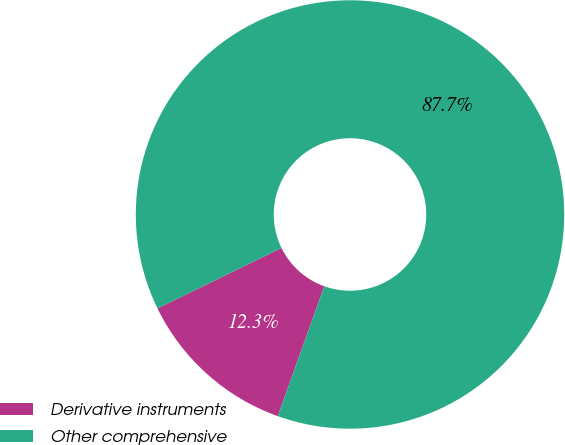Convert chart. <chart><loc_0><loc_0><loc_500><loc_500><pie_chart><fcel>Derivative instruments<fcel>Other comprehensive<nl><fcel>12.3%<fcel>87.7%<nl></chart> 